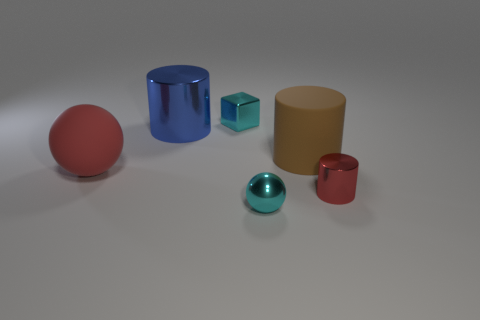Do the small red shiny object and the red object on the left side of the cyan ball have the same shape?
Offer a terse response. No. What number of things are cyan things behind the large rubber cylinder or small shiny things behind the tiny cyan sphere?
Ensure brevity in your answer.  2. What is the material of the block?
Offer a terse response. Metal. What number of other things are the same size as the red ball?
Offer a terse response. 2. There is a shiny cylinder on the right side of the blue object; what is its size?
Your answer should be very brief. Small. What is the material of the cyan thing that is on the right side of the cyan object behind the blue metal cylinder that is to the left of the small block?
Give a very brief answer. Metal. Is the shape of the small red metallic thing the same as the big brown rubber thing?
Your answer should be compact. Yes. What number of metallic things are either red cylinders or big blue cylinders?
Offer a terse response. 2. What number of large rubber balls are there?
Give a very brief answer. 1. The other metallic cylinder that is the same size as the brown cylinder is what color?
Offer a very short reply. Blue. 